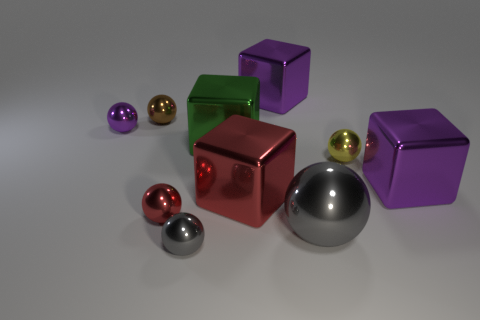Subtract 1 balls. How many balls are left? 5 Subtract all gray spheres. How many spheres are left? 4 Subtract all tiny brown metallic spheres. How many spheres are left? 5 Subtract all brown balls. Subtract all purple cylinders. How many balls are left? 5 Subtract all cubes. How many objects are left? 6 Subtract all large red metallic objects. Subtract all brown shiny spheres. How many objects are left? 8 Add 5 tiny purple metallic things. How many tiny purple metallic things are left? 6 Add 7 tiny purple metal balls. How many tiny purple metal balls exist? 8 Subtract 0 yellow cubes. How many objects are left? 10 